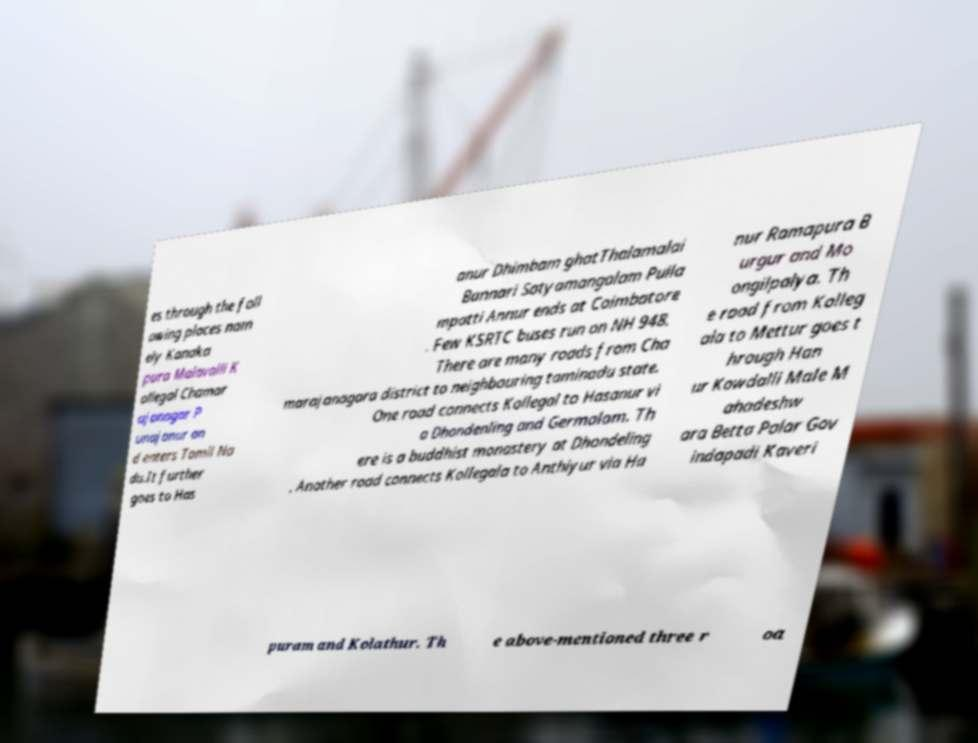There's text embedded in this image that I need extracted. Can you transcribe it verbatim? es through the foll owing places nam ely Kanaka pura Malavalli K ollegal Chamar ajanagar P unajanur an d enters Tamil Na du.It further goes to Has anur Dhimbam ghatThalamalai Bannari Satyamangalam Pulla mpatti Annur ends at Coimbatore . Few KSRTC buses run on NH 948. There are many roads from Cha marajanagara district to neighbouring taminadu state. One road connects Kollegal to Hasanur vi a Dhondenling and Germalam. Th ere is a buddhist monastery at Dhondeling . Another road connects Kollegala to Anthiyur via Ha nur Ramapura B urgur and Mo ongilpalya. Th e road from Kolleg ala to Mettur goes t hrough Han ur Kowdalli Male M ahadeshw ara Betta Palar Gov indapadi Kaveri puram and Kolathur. Th e above-mentioned three r oa 